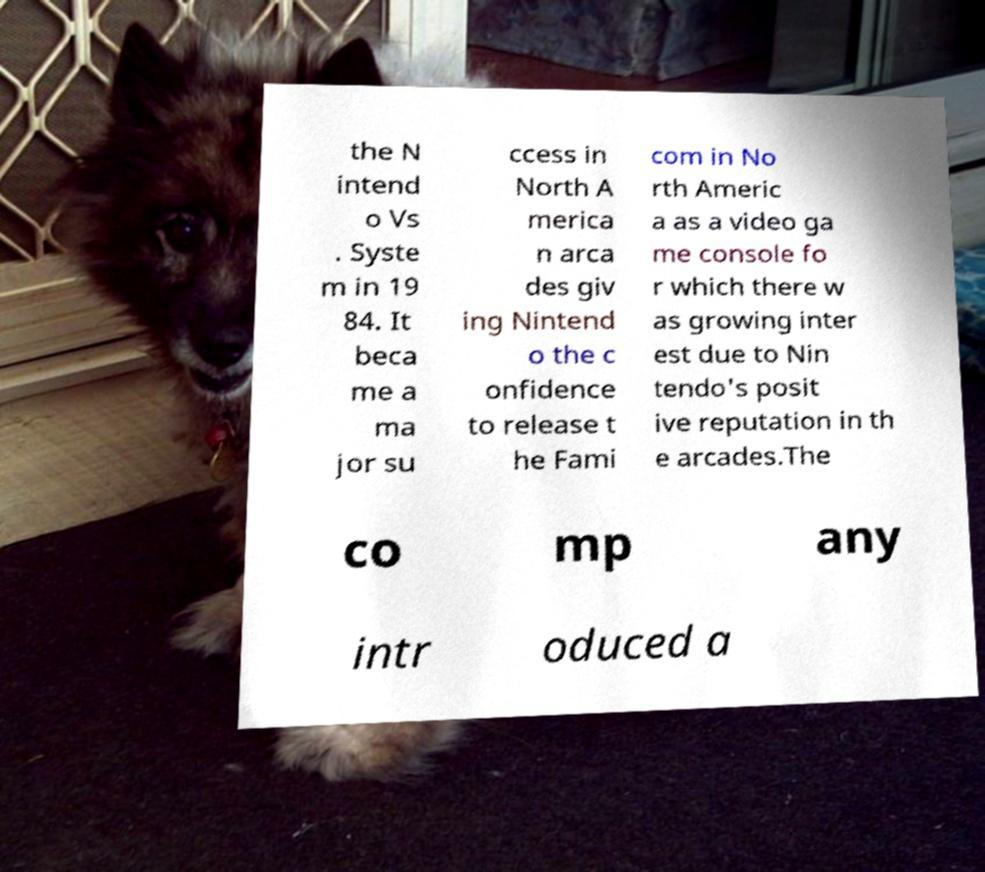What messages or text are displayed in this image? I need them in a readable, typed format. the N intend o Vs . Syste m in 19 84. It beca me a ma jor su ccess in North A merica n arca des giv ing Nintend o the c onfidence to release t he Fami com in No rth Americ a as a video ga me console fo r which there w as growing inter est due to Nin tendo's posit ive reputation in th e arcades.The co mp any intr oduced a 